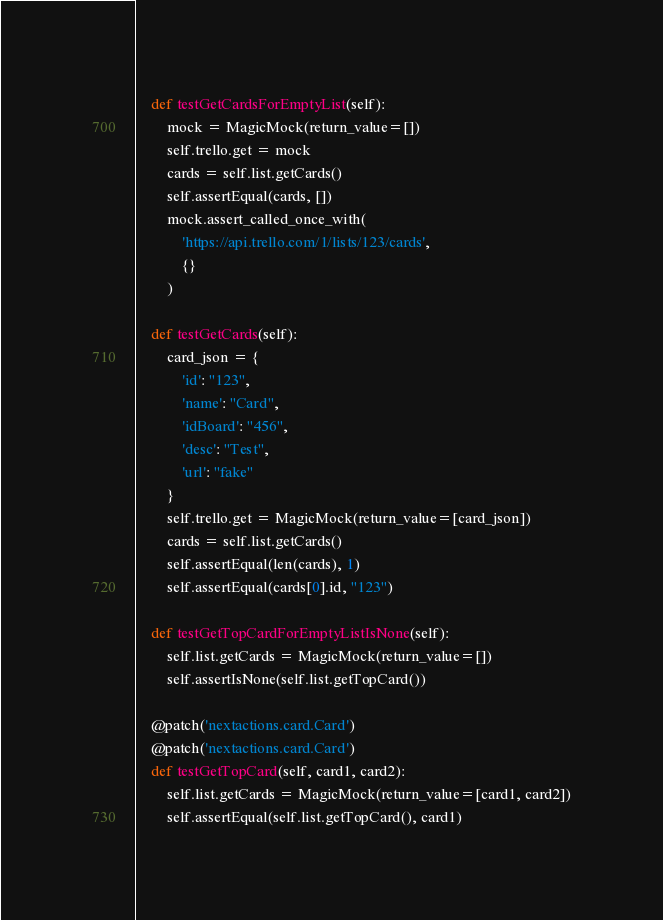<code> <loc_0><loc_0><loc_500><loc_500><_Python_>
    def testGetCardsForEmptyList(self):
        mock = MagicMock(return_value=[])
        self.trello.get = mock
        cards = self.list.getCards()
        self.assertEqual(cards, [])
        mock.assert_called_once_with(
            'https://api.trello.com/1/lists/123/cards',
            {}
        )

    def testGetCards(self):
        card_json = {
            'id': "123",
            'name': "Card",
            'idBoard': "456",
            'desc': "Test",
            'url': "fake"
        }
        self.trello.get = MagicMock(return_value=[card_json])
        cards = self.list.getCards()
        self.assertEqual(len(cards), 1)
        self.assertEqual(cards[0].id, "123")

    def testGetTopCardForEmptyListIsNone(self):
        self.list.getCards = MagicMock(return_value=[])
        self.assertIsNone(self.list.getTopCard())

    @patch('nextactions.card.Card')
    @patch('nextactions.card.Card')
    def testGetTopCard(self, card1, card2):
        self.list.getCards = MagicMock(return_value=[card1, card2])
        self.assertEqual(self.list.getTopCard(), card1)
</code> 